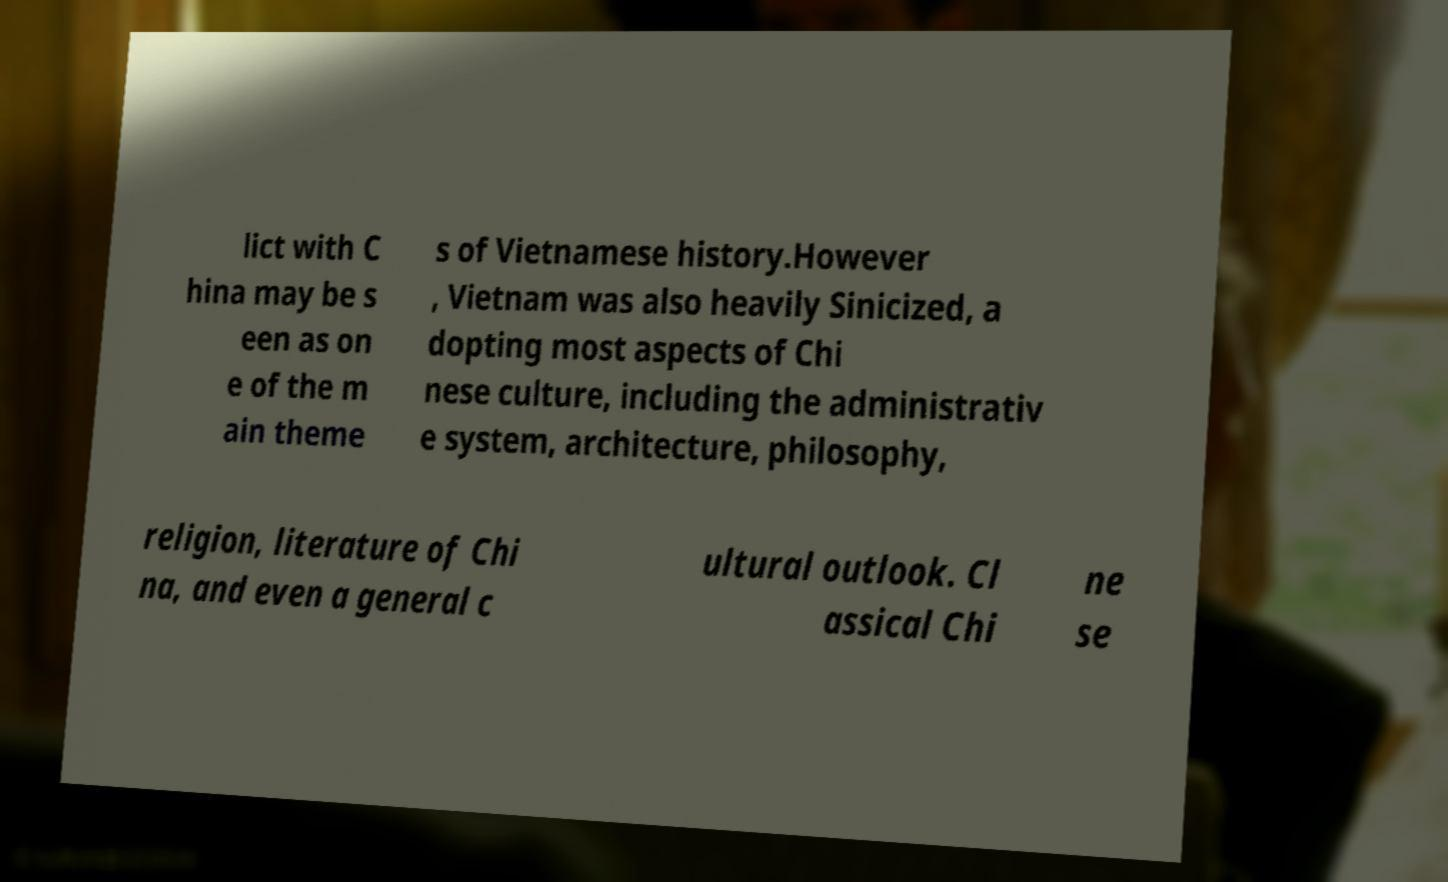What messages or text are displayed in this image? I need them in a readable, typed format. lict with C hina may be s een as on e of the m ain theme s of Vietnamese history.However , Vietnam was also heavily Sinicized, a dopting most aspects of Chi nese culture, including the administrativ e system, architecture, philosophy, religion, literature of Chi na, and even a general c ultural outlook. Cl assical Chi ne se 